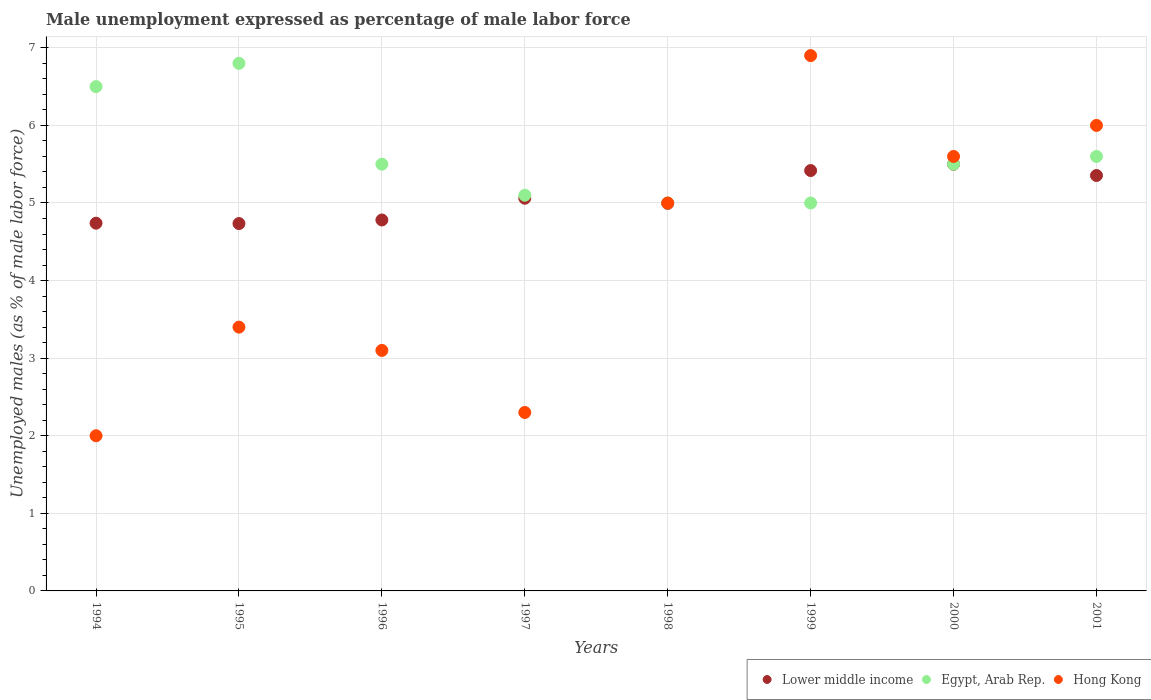Across all years, what is the maximum unemployment in males in in Egypt, Arab Rep.?
Provide a short and direct response. 6.8. Across all years, what is the minimum unemployment in males in in Egypt, Arab Rep.?
Offer a terse response. 5. In which year was the unemployment in males in in Lower middle income maximum?
Your answer should be compact. 2000. In which year was the unemployment in males in in Lower middle income minimum?
Keep it short and to the point. 1995. What is the total unemployment in males in in Hong Kong in the graph?
Your answer should be compact. 34.3. What is the difference between the unemployment in males in in Lower middle income in 1996 and that in 2000?
Offer a very short reply. -0.72. What is the difference between the unemployment in males in in Lower middle income in 1994 and the unemployment in males in in Egypt, Arab Rep. in 2000?
Give a very brief answer. -0.76. What is the average unemployment in males in in Egypt, Arab Rep. per year?
Provide a succinct answer. 5.62. In the year 1997, what is the difference between the unemployment in males in in Hong Kong and unemployment in males in in Lower middle income?
Give a very brief answer. -2.76. In how many years, is the unemployment in males in in Hong Kong greater than 4.2 %?
Offer a very short reply. 4. What is the ratio of the unemployment in males in in Egypt, Arab Rep. in 1997 to that in 2001?
Ensure brevity in your answer.  0.91. What is the difference between the highest and the second highest unemployment in males in in Egypt, Arab Rep.?
Give a very brief answer. 0.3. What is the difference between the highest and the lowest unemployment in males in in Lower middle income?
Offer a terse response. 0.76. In how many years, is the unemployment in males in in Hong Kong greater than the average unemployment in males in in Hong Kong taken over all years?
Offer a terse response. 4. Is it the case that in every year, the sum of the unemployment in males in in Hong Kong and unemployment in males in in Lower middle income  is greater than the unemployment in males in in Egypt, Arab Rep.?
Your response must be concise. Yes. Does the unemployment in males in in Hong Kong monotonically increase over the years?
Provide a short and direct response. No. How many dotlines are there?
Keep it short and to the point. 3. What is the difference between two consecutive major ticks on the Y-axis?
Your answer should be compact. 1. Are the values on the major ticks of Y-axis written in scientific E-notation?
Provide a short and direct response. No. Does the graph contain grids?
Make the answer very short. Yes. How many legend labels are there?
Provide a succinct answer. 3. How are the legend labels stacked?
Provide a short and direct response. Horizontal. What is the title of the graph?
Keep it short and to the point. Male unemployment expressed as percentage of male labor force. Does "Somalia" appear as one of the legend labels in the graph?
Your answer should be very brief. No. What is the label or title of the Y-axis?
Provide a short and direct response. Unemployed males (as % of male labor force). What is the Unemployed males (as % of male labor force) in Lower middle income in 1994?
Keep it short and to the point. 4.74. What is the Unemployed males (as % of male labor force) in Egypt, Arab Rep. in 1994?
Offer a very short reply. 6.5. What is the Unemployed males (as % of male labor force) of Lower middle income in 1995?
Offer a very short reply. 4.74. What is the Unemployed males (as % of male labor force) in Egypt, Arab Rep. in 1995?
Provide a short and direct response. 6.8. What is the Unemployed males (as % of male labor force) of Hong Kong in 1995?
Your response must be concise. 3.4. What is the Unemployed males (as % of male labor force) in Lower middle income in 1996?
Your response must be concise. 4.78. What is the Unemployed males (as % of male labor force) in Hong Kong in 1996?
Your response must be concise. 3.1. What is the Unemployed males (as % of male labor force) of Lower middle income in 1997?
Make the answer very short. 5.06. What is the Unemployed males (as % of male labor force) of Egypt, Arab Rep. in 1997?
Offer a very short reply. 5.1. What is the Unemployed males (as % of male labor force) of Hong Kong in 1997?
Offer a terse response. 2.3. What is the Unemployed males (as % of male labor force) of Lower middle income in 1998?
Make the answer very short. 4.99. What is the Unemployed males (as % of male labor force) in Hong Kong in 1998?
Your response must be concise. 5. What is the Unemployed males (as % of male labor force) in Lower middle income in 1999?
Give a very brief answer. 5.42. What is the Unemployed males (as % of male labor force) of Hong Kong in 1999?
Provide a short and direct response. 6.9. What is the Unemployed males (as % of male labor force) in Lower middle income in 2000?
Make the answer very short. 5.5. What is the Unemployed males (as % of male labor force) in Egypt, Arab Rep. in 2000?
Keep it short and to the point. 5.5. What is the Unemployed males (as % of male labor force) in Hong Kong in 2000?
Ensure brevity in your answer.  5.6. What is the Unemployed males (as % of male labor force) in Lower middle income in 2001?
Give a very brief answer. 5.35. What is the Unemployed males (as % of male labor force) of Egypt, Arab Rep. in 2001?
Your response must be concise. 5.6. What is the Unemployed males (as % of male labor force) of Hong Kong in 2001?
Offer a very short reply. 6. Across all years, what is the maximum Unemployed males (as % of male labor force) in Lower middle income?
Give a very brief answer. 5.5. Across all years, what is the maximum Unemployed males (as % of male labor force) in Egypt, Arab Rep.?
Your response must be concise. 6.8. Across all years, what is the maximum Unemployed males (as % of male labor force) in Hong Kong?
Keep it short and to the point. 6.9. Across all years, what is the minimum Unemployed males (as % of male labor force) of Lower middle income?
Offer a very short reply. 4.74. Across all years, what is the minimum Unemployed males (as % of male labor force) in Egypt, Arab Rep.?
Your response must be concise. 5. What is the total Unemployed males (as % of male labor force) of Lower middle income in the graph?
Provide a short and direct response. 40.58. What is the total Unemployed males (as % of male labor force) in Egypt, Arab Rep. in the graph?
Your answer should be compact. 45. What is the total Unemployed males (as % of male labor force) of Hong Kong in the graph?
Provide a short and direct response. 34.3. What is the difference between the Unemployed males (as % of male labor force) in Lower middle income in 1994 and that in 1995?
Your answer should be very brief. 0. What is the difference between the Unemployed males (as % of male labor force) in Egypt, Arab Rep. in 1994 and that in 1995?
Ensure brevity in your answer.  -0.3. What is the difference between the Unemployed males (as % of male labor force) in Lower middle income in 1994 and that in 1996?
Ensure brevity in your answer.  -0.04. What is the difference between the Unemployed males (as % of male labor force) in Lower middle income in 1994 and that in 1997?
Your answer should be compact. -0.32. What is the difference between the Unemployed males (as % of male labor force) of Egypt, Arab Rep. in 1994 and that in 1997?
Your answer should be very brief. 1.4. What is the difference between the Unemployed males (as % of male labor force) in Lower middle income in 1994 and that in 1998?
Your answer should be very brief. -0.25. What is the difference between the Unemployed males (as % of male labor force) in Hong Kong in 1994 and that in 1998?
Make the answer very short. -3. What is the difference between the Unemployed males (as % of male labor force) of Lower middle income in 1994 and that in 1999?
Provide a succinct answer. -0.68. What is the difference between the Unemployed males (as % of male labor force) in Egypt, Arab Rep. in 1994 and that in 1999?
Provide a succinct answer. 1.5. What is the difference between the Unemployed males (as % of male labor force) in Lower middle income in 1994 and that in 2000?
Your answer should be compact. -0.76. What is the difference between the Unemployed males (as % of male labor force) in Egypt, Arab Rep. in 1994 and that in 2000?
Keep it short and to the point. 1. What is the difference between the Unemployed males (as % of male labor force) in Lower middle income in 1994 and that in 2001?
Offer a terse response. -0.61. What is the difference between the Unemployed males (as % of male labor force) in Egypt, Arab Rep. in 1994 and that in 2001?
Make the answer very short. 0.9. What is the difference between the Unemployed males (as % of male labor force) in Hong Kong in 1994 and that in 2001?
Make the answer very short. -4. What is the difference between the Unemployed males (as % of male labor force) of Lower middle income in 1995 and that in 1996?
Keep it short and to the point. -0.05. What is the difference between the Unemployed males (as % of male labor force) of Hong Kong in 1995 and that in 1996?
Offer a very short reply. 0.3. What is the difference between the Unemployed males (as % of male labor force) in Lower middle income in 1995 and that in 1997?
Keep it short and to the point. -0.33. What is the difference between the Unemployed males (as % of male labor force) in Lower middle income in 1995 and that in 1998?
Your answer should be very brief. -0.26. What is the difference between the Unemployed males (as % of male labor force) in Egypt, Arab Rep. in 1995 and that in 1998?
Keep it short and to the point. 1.8. What is the difference between the Unemployed males (as % of male labor force) of Lower middle income in 1995 and that in 1999?
Keep it short and to the point. -0.68. What is the difference between the Unemployed males (as % of male labor force) of Egypt, Arab Rep. in 1995 and that in 1999?
Make the answer very short. 1.8. What is the difference between the Unemployed males (as % of male labor force) of Hong Kong in 1995 and that in 1999?
Offer a very short reply. -3.5. What is the difference between the Unemployed males (as % of male labor force) of Lower middle income in 1995 and that in 2000?
Make the answer very short. -0.76. What is the difference between the Unemployed males (as % of male labor force) of Egypt, Arab Rep. in 1995 and that in 2000?
Your answer should be compact. 1.3. What is the difference between the Unemployed males (as % of male labor force) of Hong Kong in 1995 and that in 2000?
Keep it short and to the point. -2.2. What is the difference between the Unemployed males (as % of male labor force) in Lower middle income in 1995 and that in 2001?
Offer a terse response. -0.62. What is the difference between the Unemployed males (as % of male labor force) of Hong Kong in 1995 and that in 2001?
Give a very brief answer. -2.6. What is the difference between the Unemployed males (as % of male labor force) in Lower middle income in 1996 and that in 1997?
Your response must be concise. -0.28. What is the difference between the Unemployed males (as % of male labor force) of Egypt, Arab Rep. in 1996 and that in 1997?
Give a very brief answer. 0.4. What is the difference between the Unemployed males (as % of male labor force) in Lower middle income in 1996 and that in 1998?
Your answer should be very brief. -0.21. What is the difference between the Unemployed males (as % of male labor force) in Egypt, Arab Rep. in 1996 and that in 1998?
Provide a succinct answer. 0.5. What is the difference between the Unemployed males (as % of male labor force) in Hong Kong in 1996 and that in 1998?
Ensure brevity in your answer.  -1.9. What is the difference between the Unemployed males (as % of male labor force) in Lower middle income in 1996 and that in 1999?
Make the answer very short. -0.64. What is the difference between the Unemployed males (as % of male labor force) in Egypt, Arab Rep. in 1996 and that in 1999?
Your response must be concise. 0.5. What is the difference between the Unemployed males (as % of male labor force) in Hong Kong in 1996 and that in 1999?
Provide a short and direct response. -3.8. What is the difference between the Unemployed males (as % of male labor force) in Lower middle income in 1996 and that in 2000?
Your answer should be compact. -0.72. What is the difference between the Unemployed males (as % of male labor force) of Egypt, Arab Rep. in 1996 and that in 2000?
Offer a terse response. 0. What is the difference between the Unemployed males (as % of male labor force) in Hong Kong in 1996 and that in 2000?
Keep it short and to the point. -2.5. What is the difference between the Unemployed males (as % of male labor force) in Lower middle income in 1996 and that in 2001?
Offer a terse response. -0.57. What is the difference between the Unemployed males (as % of male labor force) of Egypt, Arab Rep. in 1996 and that in 2001?
Your response must be concise. -0.1. What is the difference between the Unemployed males (as % of male labor force) in Lower middle income in 1997 and that in 1998?
Your answer should be compact. 0.07. What is the difference between the Unemployed males (as % of male labor force) of Lower middle income in 1997 and that in 1999?
Keep it short and to the point. -0.36. What is the difference between the Unemployed males (as % of male labor force) in Egypt, Arab Rep. in 1997 and that in 1999?
Provide a succinct answer. 0.1. What is the difference between the Unemployed males (as % of male labor force) in Hong Kong in 1997 and that in 1999?
Provide a short and direct response. -4.6. What is the difference between the Unemployed males (as % of male labor force) in Lower middle income in 1997 and that in 2000?
Your response must be concise. -0.44. What is the difference between the Unemployed males (as % of male labor force) of Egypt, Arab Rep. in 1997 and that in 2000?
Provide a succinct answer. -0.4. What is the difference between the Unemployed males (as % of male labor force) in Lower middle income in 1997 and that in 2001?
Provide a succinct answer. -0.29. What is the difference between the Unemployed males (as % of male labor force) in Lower middle income in 1998 and that in 1999?
Your answer should be very brief. -0.42. What is the difference between the Unemployed males (as % of male labor force) of Egypt, Arab Rep. in 1998 and that in 1999?
Offer a terse response. 0. What is the difference between the Unemployed males (as % of male labor force) of Hong Kong in 1998 and that in 1999?
Your answer should be very brief. -1.9. What is the difference between the Unemployed males (as % of male labor force) of Lower middle income in 1998 and that in 2000?
Your answer should be compact. -0.51. What is the difference between the Unemployed males (as % of male labor force) in Lower middle income in 1998 and that in 2001?
Keep it short and to the point. -0.36. What is the difference between the Unemployed males (as % of male labor force) of Egypt, Arab Rep. in 1998 and that in 2001?
Keep it short and to the point. -0.6. What is the difference between the Unemployed males (as % of male labor force) of Hong Kong in 1998 and that in 2001?
Offer a terse response. -1. What is the difference between the Unemployed males (as % of male labor force) of Lower middle income in 1999 and that in 2000?
Offer a terse response. -0.08. What is the difference between the Unemployed males (as % of male labor force) in Egypt, Arab Rep. in 1999 and that in 2000?
Make the answer very short. -0.5. What is the difference between the Unemployed males (as % of male labor force) of Lower middle income in 1999 and that in 2001?
Your response must be concise. 0.06. What is the difference between the Unemployed males (as % of male labor force) of Egypt, Arab Rep. in 1999 and that in 2001?
Offer a terse response. -0.6. What is the difference between the Unemployed males (as % of male labor force) in Lower middle income in 2000 and that in 2001?
Your answer should be very brief. 0.14. What is the difference between the Unemployed males (as % of male labor force) of Lower middle income in 1994 and the Unemployed males (as % of male labor force) of Egypt, Arab Rep. in 1995?
Offer a very short reply. -2.06. What is the difference between the Unemployed males (as % of male labor force) of Lower middle income in 1994 and the Unemployed males (as % of male labor force) of Hong Kong in 1995?
Give a very brief answer. 1.34. What is the difference between the Unemployed males (as % of male labor force) of Lower middle income in 1994 and the Unemployed males (as % of male labor force) of Egypt, Arab Rep. in 1996?
Provide a short and direct response. -0.76. What is the difference between the Unemployed males (as % of male labor force) of Lower middle income in 1994 and the Unemployed males (as % of male labor force) of Hong Kong in 1996?
Your answer should be very brief. 1.64. What is the difference between the Unemployed males (as % of male labor force) in Lower middle income in 1994 and the Unemployed males (as % of male labor force) in Egypt, Arab Rep. in 1997?
Offer a very short reply. -0.36. What is the difference between the Unemployed males (as % of male labor force) in Lower middle income in 1994 and the Unemployed males (as % of male labor force) in Hong Kong in 1997?
Give a very brief answer. 2.44. What is the difference between the Unemployed males (as % of male labor force) in Lower middle income in 1994 and the Unemployed males (as % of male labor force) in Egypt, Arab Rep. in 1998?
Offer a very short reply. -0.26. What is the difference between the Unemployed males (as % of male labor force) in Lower middle income in 1994 and the Unemployed males (as % of male labor force) in Hong Kong in 1998?
Make the answer very short. -0.26. What is the difference between the Unemployed males (as % of male labor force) in Lower middle income in 1994 and the Unemployed males (as % of male labor force) in Egypt, Arab Rep. in 1999?
Your response must be concise. -0.26. What is the difference between the Unemployed males (as % of male labor force) in Lower middle income in 1994 and the Unemployed males (as % of male labor force) in Hong Kong in 1999?
Your answer should be very brief. -2.16. What is the difference between the Unemployed males (as % of male labor force) in Lower middle income in 1994 and the Unemployed males (as % of male labor force) in Egypt, Arab Rep. in 2000?
Give a very brief answer. -0.76. What is the difference between the Unemployed males (as % of male labor force) of Lower middle income in 1994 and the Unemployed males (as % of male labor force) of Hong Kong in 2000?
Your response must be concise. -0.86. What is the difference between the Unemployed males (as % of male labor force) in Lower middle income in 1994 and the Unemployed males (as % of male labor force) in Egypt, Arab Rep. in 2001?
Provide a succinct answer. -0.86. What is the difference between the Unemployed males (as % of male labor force) of Lower middle income in 1994 and the Unemployed males (as % of male labor force) of Hong Kong in 2001?
Your answer should be compact. -1.26. What is the difference between the Unemployed males (as % of male labor force) of Egypt, Arab Rep. in 1994 and the Unemployed males (as % of male labor force) of Hong Kong in 2001?
Provide a succinct answer. 0.5. What is the difference between the Unemployed males (as % of male labor force) of Lower middle income in 1995 and the Unemployed males (as % of male labor force) of Egypt, Arab Rep. in 1996?
Provide a short and direct response. -0.76. What is the difference between the Unemployed males (as % of male labor force) in Lower middle income in 1995 and the Unemployed males (as % of male labor force) in Hong Kong in 1996?
Provide a succinct answer. 1.64. What is the difference between the Unemployed males (as % of male labor force) of Egypt, Arab Rep. in 1995 and the Unemployed males (as % of male labor force) of Hong Kong in 1996?
Keep it short and to the point. 3.7. What is the difference between the Unemployed males (as % of male labor force) of Lower middle income in 1995 and the Unemployed males (as % of male labor force) of Egypt, Arab Rep. in 1997?
Offer a terse response. -0.36. What is the difference between the Unemployed males (as % of male labor force) of Lower middle income in 1995 and the Unemployed males (as % of male labor force) of Hong Kong in 1997?
Keep it short and to the point. 2.44. What is the difference between the Unemployed males (as % of male labor force) in Egypt, Arab Rep. in 1995 and the Unemployed males (as % of male labor force) in Hong Kong in 1997?
Provide a short and direct response. 4.5. What is the difference between the Unemployed males (as % of male labor force) of Lower middle income in 1995 and the Unemployed males (as % of male labor force) of Egypt, Arab Rep. in 1998?
Offer a terse response. -0.26. What is the difference between the Unemployed males (as % of male labor force) in Lower middle income in 1995 and the Unemployed males (as % of male labor force) in Hong Kong in 1998?
Your answer should be compact. -0.26. What is the difference between the Unemployed males (as % of male labor force) of Egypt, Arab Rep. in 1995 and the Unemployed males (as % of male labor force) of Hong Kong in 1998?
Provide a succinct answer. 1.8. What is the difference between the Unemployed males (as % of male labor force) in Lower middle income in 1995 and the Unemployed males (as % of male labor force) in Egypt, Arab Rep. in 1999?
Ensure brevity in your answer.  -0.26. What is the difference between the Unemployed males (as % of male labor force) of Lower middle income in 1995 and the Unemployed males (as % of male labor force) of Hong Kong in 1999?
Ensure brevity in your answer.  -2.16. What is the difference between the Unemployed males (as % of male labor force) in Egypt, Arab Rep. in 1995 and the Unemployed males (as % of male labor force) in Hong Kong in 1999?
Make the answer very short. -0.1. What is the difference between the Unemployed males (as % of male labor force) of Lower middle income in 1995 and the Unemployed males (as % of male labor force) of Egypt, Arab Rep. in 2000?
Give a very brief answer. -0.76. What is the difference between the Unemployed males (as % of male labor force) in Lower middle income in 1995 and the Unemployed males (as % of male labor force) in Hong Kong in 2000?
Your response must be concise. -0.86. What is the difference between the Unemployed males (as % of male labor force) of Egypt, Arab Rep. in 1995 and the Unemployed males (as % of male labor force) of Hong Kong in 2000?
Your response must be concise. 1.2. What is the difference between the Unemployed males (as % of male labor force) of Lower middle income in 1995 and the Unemployed males (as % of male labor force) of Egypt, Arab Rep. in 2001?
Your response must be concise. -0.86. What is the difference between the Unemployed males (as % of male labor force) in Lower middle income in 1995 and the Unemployed males (as % of male labor force) in Hong Kong in 2001?
Keep it short and to the point. -1.26. What is the difference between the Unemployed males (as % of male labor force) in Lower middle income in 1996 and the Unemployed males (as % of male labor force) in Egypt, Arab Rep. in 1997?
Provide a succinct answer. -0.32. What is the difference between the Unemployed males (as % of male labor force) of Lower middle income in 1996 and the Unemployed males (as % of male labor force) of Hong Kong in 1997?
Your answer should be compact. 2.48. What is the difference between the Unemployed males (as % of male labor force) in Lower middle income in 1996 and the Unemployed males (as % of male labor force) in Egypt, Arab Rep. in 1998?
Ensure brevity in your answer.  -0.22. What is the difference between the Unemployed males (as % of male labor force) in Lower middle income in 1996 and the Unemployed males (as % of male labor force) in Hong Kong in 1998?
Give a very brief answer. -0.22. What is the difference between the Unemployed males (as % of male labor force) of Lower middle income in 1996 and the Unemployed males (as % of male labor force) of Egypt, Arab Rep. in 1999?
Provide a succinct answer. -0.22. What is the difference between the Unemployed males (as % of male labor force) of Lower middle income in 1996 and the Unemployed males (as % of male labor force) of Hong Kong in 1999?
Offer a terse response. -2.12. What is the difference between the Unemployed males (as % of male labor force) of Egypt, Arab Rep. in 1996 and the Unemployed males (as % of male labor force) of Hong Kong in 1999?
Offer a terse response. -1.4. What is the difference between the Unemployed males (as % of male labor force) in Lower middle income in 1996 and the Unemployed males (as % of male labor force) in Egypt, Arab Rep. in 2000?
Your response must be concise. -0.72. What is the difference between the Unemployed males (as % of male labor force) in Lower middle income in 1996 and the Unemployed males (as % of male labor force) in Hong Kong in 2000?
Your answer should be very brief. -0.82. What is the difference between the Unemployed males (as % of male labor force) of Egypt, Arab Rep. in 1996 and the Unemployed males (as % of male labor force) of Hong Kong in 2000?
Keep it short and to the point. -0.1. What is the difference between the Unemployed males (as % of male labor force) of Lower middle income in 1996 and the Unemployed males (as % of male labor force) of Egypt, Arab Rep. in 2001?
Provide a short and direct response. -0.82. What is the difference between the Unemployed males (as % of male labor force) in Lower middle income in 1996 and the Unemployed males (as % of male labor force) in Hong Kong in 2001?
Provide a succinct answer. -1.22. What is the difference between the Unemployed males (as % of male labor force) in Egypt, Arab Rep. in 1996 and the Unemployed males (as % of male labor force) in Hong Kong in 2001?
Keep it short and to the point. -0.5. What is the difference between the Unemployed males (as % of male labor force) of Lower middle income in 1997 and the Unemployed males (as % of male labor force) of Egypt, Arab Rep. in 1998?
Give a very brief answer. 0.06. What is the difference between the Unemployed males (as % of male labor force) of Lower middle income in 1997 and the Unemployed males (as % of male labor force) of Hong Kong in 1998?
Make the answer very short. 0.06. What is the difference between the Unemployed males (as % of male labor force) in Lower middle income in 1997 and the Unemployed males (as % of male labor force) in Egypt, Arab Rep. in 1999?
Keep it short and to the point. 0.06. What is the difference between the Unemployed males (as % of male labor force) of Lower middle income in 1997 and the Unemployed males (as % of male labor force) of Hong Kong in 1999?
Your response must be concise. -1.84. What is the difference between the Unemployed males (as % of male labor force) of Lower middle income in 1997 and the Unemployed males (as % of male labor force) of Egypt, Arab Rep. in 2000?
Ensure brevity in your answer.  -0.44. What is the difference between the Unemployed males (as % of male labor force) in Lower middle income in 1997 and the Unemployed males (as % of male labor force) in Hong Kong in 2000?
Give a very brief answer. -0.54. What is the difference between the Unemployed males (as % of male labor force) in Lower middle income in 1997 and the Unemployed males (as % of male labor force) in Egypt, Arab Rep. in 2001?
Provide a short and direct response. -0.54. What is the difference between the Unemployed males (as % of male labor force) in Lower middle income in 1997 and the Unemployed males (as % of male labor force) in Hong Kong in 2001?
Give a very brief answer. -0.94. What is the difference between the Unemployed males (as % of male labor force) in Egypt, Arab Rep. in 1997 and the Unemployed males (as % of male labor force) in Hong Kong in 2001?
Ensure brevity in your answer.  -0.9. What is the difference between the Unemployed males (as % of male labor force) of Lower middle income in 1998 and the Unemployed males (as % of male labor force) of Egypt, Arab Rep. in 1999?
Provide a short and direct response. -0.01. What is the difference between the Unemployed males (as % of male labor force) in Lower middle income in 1998 and the Unemployed males (as % of male labor force) in Hong Kong in 1999?
Your answer should be very brief. -1.91. What is the difference between the Unemployed males (as % of male labor force) in Egypt, Arab Rep. in 1998 and the Unemployed males (as % of male labor force) in Hong Kong in 1999?
Keep it short and to the point. -1.9. What is the difference between the Unemployed males (as % of male labor force) of Lower middle income in 1998 and the Unemployed males (as % of male labor force) of Egypt, Arab Rep. in 2000?
Your answer should be very brief. -0.51. What is the difference between the Unemployed males (as % of male labor force) in Lower middle income in 1998 and the Unemployed males (as % of male labor force) in Hong Kong in 2000?
Offer a terse response. -0.61. What is the difference between the Unemployed males (as % of male labor force) in Lower middle income in 1998 and the Unemployed males (as % of male labor force) in Egypt, Arab Rep. in 2001?
Provide a short and direct response. -0.61. What is the difference between the Unemployed males (as % of male labor force) of Lower middle income in 1998 and the Unemployed males (as % of male labor force) of Hong Kong in 2001?
Give a very brief answer. -1.01. What is the difference between the Unemployed males (as % of male labor force) of Egypt, Arab Rep. in 1998 and the Unemployed males (as % of male labor force) of Hong Kong in 2001?
Your response must be concise. -1. What is the difference between the Unemployed males (as % of male labor force) in Lower middle income in 1999 and the Unemployed males (as % of male labor force) in Egypt, Arab Rep. in 2000?
Your answer should be very brief. -0.08. What is the difference between the Unemployed males (as % of male labor force) of Lower middle income in 1999 and the Unemployed males (as % of male labor force) of Hong Kong in 2000?
Offer a very short reply. -0.18. What is the difference between the Unemployed males (as % of male labor force) in Egypt, Arab Rep. in 1999 and the Unemployed males (as % of male labor force) in Hong Kong in 2000?
Keep it short and to the point. -0.6. What is the difference between the Unemployed males (as % of male labor force) of Lower middle income in 1999 and the Unemployed males (as % of male labor force) of Egypt, Arab Rep. in 2001?
Provide a succinct answer. -0.18. What is the difference between the Unemployed males (as % of male labor force) in Lower middle income in 1999 and the Unemployed males (as % of male labor force) in Hong Kong in 2001?
Provide a succinct answer. -0.58. What is the difference between the Unemployed males (as % of male labor force) of Egypt, Arab Rep. in 1999 and the Unemployed males (as % of male labor force) of Hong Kong in 2001?
Offer a very short reply. -1. What is the difference between the Unemployed males (as % of male labor force) in Lower middle income in 2000 and the Unemployed males (as % of male labor force) in Egypt, Arab Rep. in 2001?
Keep it short and to the point. -0.1. What is the difference between the Unemployed males (as % of male labor force) of Lower middle income in 2000 and the Unemployed males (as % of male labor force) of Hong Kong in 2001?
Your response must be concise. -0.5. What is the difference between the Unemployed males (as % of male labor force) in Egypt, Arab Rep. in 2000 and the Unemployed males (as % of male labor force) in Hong Kong in 2001?
Offer a terse response. -0.5. What is the average Unemployed males (as % of male labor force) in Lower middle income per year?
Your answer should be compact. 5.07. What is the average Unemployed males (as % of male labor force) of Egypt, Arab Rep. per year?
Give a very brief answer. 5.62. What is the average Unemployed males (as % of male labor force) of Hong Kong per year?
Provide a short and direct response. 4.29. In the year 1994, what is the difference between the Unemployed males (as % of male labor force) of Lower middle income and Unemployed males (as % of male labor force) of Egypt, Arab Rep.?
Give a very brief answer. -1.76. In the year 1994, what is the difference between the Unemployed males (as % of male labor force) in Lower middle income and Unemployed males (as % of male labor force) in Hong Kong?
Give a very brief answer. 2.74. In the year 1994, what is the difference between the Unemployed males (as % of male labor force) of Egypt, Arab Rep. and Unemployed males (as % of male labor force) of Hong Kong?
Make the answer very short. 4.5. In the year 1995, what is the difference between the Unemployed males (as % of male labor force) of Lower middle income and Unemployed males (as % of male labor force) of Egypt, Arab Rep.?
Your answer should be very brief. -2.06. In the year 1995, what is the difference between the Unemployed males (as % of male labor force) in Lower middle income and Unemployed males (as % of male labor force) in Hong Kong?
Your answer should be very brief. 1.34. In the year 1996, what is the difference between the Unemployed males (as % of male labor force) in Lower middle income and Unemployed males (as % of male labor force) in Egypt, Arab Rep.?
Give a very brief answer. -0.72. In the year 1996, what is the difference between the Unemployed males (as % of male labor force) in Lower middle income and Unemployed males (as % of male labor force) in Hong Kong?
Your answer should be very brief. 1.68. In the year 1997, what is the difference between the Unemployed males (as % of male labor force) of Lower middle income and Unemployed males (as % of male labor force) of Egypt, Arab Rep.?
Provide a short and direct response. -0.04. In the year 1997, what is the difference between the Unemployed males (as % of male labor force) of Lower middle income and Unemployed males (as % of male labor force) of Hong Kong?
Your response must be concise. 2.76. In the year 1997, what is the difference between the Unemployed males (as % of male labor force) of Egypt, Arab Rep. and Unemployed males (as % of male labor force) of Hong Kong?
Give a very brief answer. 2.8. In the year 1998, what is the difference between the Unemployed males (as % of male labor force) of Lower middle income and Unemployed males (as % of male labor force) of Egypt, Arab Rep.?
Your answer should be compact. -0.01. In the year 1998, what is the difference between the Unemployed males (as % of male labor force) of Lower middle income and Unemployed males (as % of male labor force) of Hong Kong?
Your response must be concise. -0.01. In the year 1999, what is the difference between the Unemployed males (as % of male labor force) of Lower middle income and Unemployed males (as % of male labor force) of Egypt, Arab Rep.?
Your answer should be compact. 0.42. In the year 1999, what is the difference between the Unemployed males (as % of male labor force) in Lower middle income and Unemployed males (as % of male labor force) in Hong Kong?
Your answer should be compact. -1.48. In the year 1999, what is the difference between the Unemployed males (as % of male labor force) of Egypt, Arab Rep. and Unemployed males (as % of male labor force) of Hong Kong?
Give a very brief answer. -1.9. In the year 2000, what is the difference between the Unemployed males (as % of male labor force) in Lower middle income and Unemployed males (as % of male labor force) in Egypt, Arab Rep.?
Provide a short and direct response. -0. In the year 2000, what is the difference between the Unemployed males (as % of male labor force) in Lower middle income and Unemployed males (as % of male labor force) in Hong Kong?
Your answer should be very brief. -0.1. In the year 2000, what is the difference between the Unemployed males (as % of male labor force) of Egypt, Arab Rep. and Unemployed males (as % of male labor force) of Hong Kong?
Ensure brevity in your answer.  -0.1. In the year 2001, what is the difference between the Unemployed males (as % of male labor force) of Lower middle income and Unemployed males (as % of male labor force) of Egypt, Arab Rep.?
Ensure brevity in your answer.  -0.25. In the year 2001, what is the difference between the Unemployed males (as % of male labor force) of Lower middle income and Unemployed males (as % of male labor force) of Hong Kong?
Keep it short and to the point. -0.65. In the year 2001, what is the difference between the Unemployed males (as % of male labor force) of Egypt, Arab Rep. and Unemployed males (as % of male labor force) of Hong Kong?
Make the answer very short. -0.4. What is the ratio of the Unemployed males (as % of male labor force) of Lower middle income in 1994 to that in 1995?
Your answer should be compact. 1. What is the ratio of the Unemployed males (as % of male labor force) in Egypt, Arab Rep. in 1994 to that in 1995?
Your answer should be compact. 0.96. What is the ratio of the Unemployed males (as % of male labor force) in Hong Kong in 1994 to that in 1995?
Keep it short and to the point. 0.59. What is the ratio of the Unemployed males (as % of male labor force) of Egypt, Arab Rep. in 1994 to that in 1996?
Keep it short and to the point. 1.18. What is the ratio of the Unemployed males (as % of male labor force) in Hong Kong in 1994 to that in 1996?
Your response must be concise. 0.65. What is the ratio of the Unemployed males (as % of male labor force) in Lower middle income in 1994 to that in 1997?
Make the answer very short. 0.94. What is the ratio of the Unemployed males (as % of male labor force) of Egypt, Arab Rep. in 1994 to that in 1997?
Your answer should be very brief. 1.27. What is the ratio of the Unemployed males (as % of male labor force) in Hong Kong in 1994 to that in 1997?
Ensure brevity in your answer.  0.87. What is the ratio of the Unemployed males (as % of male labor force) in Lower middle income in 1994 to that in 1998?
Your answer should be very brief. 0.95. What is the ratio of the Unemployed males (as % of male labor force) of Egypt, Arab Rep. in 1994 to that in 1998?
Keep it short and to the point. 1.3. What is the ratio of the Unemployed males (as % of male labor force) of Lower middle income in 1994 to that in 1999?
Offer a very short reply. 0.87. What is the ratio of the Unemployed males (as % of male labor force) of Egypt, Arab Rep. in 1994 to that in 1999?
Keep it short and to the point. 1.3. What is the ratio of the Unemployed males (as % of male labor force) in Hong Kong in 1994 to that in 1999?
Offer a terse response. 0.29. What is the ratio of the Unemployed males (as % of male labor force) of Lower middle income in 1994 to that in 2000?
Offer a very short reply. 0.86. What is the ratio of the Unemployed males (as % of male labor force) of Egypt, Arab Rep. in 1994 to that in 2000?
Your answer should be very brief. 1.18. What is the ratio of the Unemployed males (as % of male labor force) in Hong Kong in 1994 to that in 2000?
Make the answer very short. 0.36. What is the ratio of the Unemployed males (as % of male labor force) in Lower middle income in 1994 to that in 2001?
Your response must be concise. 0.89. What is the ratio of the Unemployed males (as % of male labor force) in Egypt, Arab Rep. in 1994 to that in 2001?
Your response must be concise. 1.16. What is the ratio of the Unemployed males (as % of male labor force) of Lower middle income in 1995 to that in 1996?
Ensure brevity in your answer.  0.99. What is the ratio of the Unemployed males (as % of male labor force) in Egypt, Arab Rep. in 1995 to that in 1996?
Your answer should be compact. 1.24. What is the ratio of the Unemployed males (as % of male labor force) of Hong Kong in 1995 to that in 1996?
Your answer should be compact. 1.1. What is the ratio of the Unemployed males (as % of male labor force) in Lower middle income in 1995 to that in 1997?
Offer a very short reply. 0.94. What is the ratio of the Unemployed males (as % of male labor force) of Hong Kong in 1995 to that in 1997?
Your response must be concise. 1.48. What is the ratio of the Unemployed males (as % of male labor force) of Lower middle income in 1995 to that in 1998?
Ensure brevity in your answer.  0.95. What is the ratio of the Unemployed males (as % of male labor force) of Egypt, Arab Rep. in 1995 to that in 1998?
Offer a terse response. 1.36. What is the ratio of the Unemployed males (as % of male labor force) of Hong Kong in 1995 to that in 1998?
Make the answer very short. 0.68. What is the ratio of the Unemployed males (as % of male labor force) of Lower middle income in 1995 to that in 1999?
Your answer should be very brief. 0.87. What is the ratio of the Unemployed males (as % of male labor force) of Egypt, Arab Rep. in 1995 to that in 1999?
Your answer should be compact. 1.36. What is the ratio of the Unemployed males (as % of male labor force) of Hong Kong in 1995 to that in 1999?
Give a very brief answer. 0.49. What is the ratio of the Unemployed males (as % of male labor force) of Lower middle income in 1995 to that in 2000?
Your response must be concise. 0.86. What is the ratio of the Unemployed males (as % of male labor force) in Egypt, Arab Rep. in 1995 to that in 2000?
Your answer should be very brief. 1.24. What is the ratio of the Unemployed males (as % of male labor force) in Hong Kong in 1995 to that in 2000?
Ensure brevity in your answer.  0.61. What is the ratio of the Unemployed males (as % of male labor force) of Lower middle income in 1995 to that in 2001?
Make the answer very short. 0.88. What is the ratio of the Unemployed males (as % of male labor force) of Egypt, Arab Rep. in 1995 to that in 2001?
Provide a succinct answer. 1.21. What is the ratio of the Unemployed males (as % of male labor force) of Hong Kong in 1995 to that in 2001?
Offer a very short reply. 0.57. What is the ratio of the Unemployed males (as % of male labor force) in Lower middle income in 1996 to that in 1997?
Offer a very short reply. 0.94. What is the ratio of the Unemployed males (as % of male labor force) of Egypt, Arab Rep. in 1996 to that in 1997?
Ensure brevity in your answer.  1.08. What is the ratio of the Unemployed males (as % of male labor force) of Hong Kong in 1996 to that in 1997?
Provide a succinct answer. 1.35. What is the ratio of the Unemployed males (as % of male labor force) of Lower middle income in 1996 to that in 1998?
Your response must be concise. 0.96. What is the ratio of the Unemployed males (as % of male labor force) of Hong Kong in 1996 to that in 1998?
Ensure brevity in your answer.  0.62. What is the ratio of the Unemployed males (as % of male labor force) in Lower middle income in 1996 to that in 1999?
Your response must be concise. 0.88. What is the ratio of the Unemployed males (as % of male labor force) of Egypt, Arab Rep. in 1996 to that in 1999?
Make the answer very short. 1.1. What is the ratio of the Unemployed males (as % of male labor force) in Hong Kong in 1996 to that in 1999?
Make the answer very short. 0.45. What is the ratio of the Unemployed males (as % of male labor force) of Lower middle income in 1996 to that in 2000?
Provide a short and direct response. 0.87. What is the ratio of the Unemployed males (as % of male labor force) of Hong Kong in 1996 to that in 2000?
Give a very brief answer. 0.55. What is the ratio of the Unemployed males (as % of male labor force) of Lower middle income in 1996 to that in 2001?
Provide a short and direct response. 0.89. What is the ratio of the Unemployed males (as % of male labor force) in Egypt, Arab Rep. in 1996 to that in 2001?
Ensure brevity in your answer.  0.98. What is the ratio of the Unemployed males (as % of male labor force) in Hong Kong in 1996 to that in 2001?
Ensure brevity in your answer.  0.52. What is the ratio of the Unemployed males (as % of male labor force) in Lower middle income in 1997 to that in 1998?
Provide a succinct answer. 1.01. What is the ratio of the Unemployed males (as % of male labor force) in Egypt, Arab Rep. in 1997 to that in 1998?
Offer a terse response. 1.02. What is the ratio of the Unemployed males (as % of male labor force) in Hong Kong in 1997 to that in 1998?
Make the answer very short. 0.46. What is the ratio of the Unemployed males (as % of male labor force) of Lower middle income in 1997 to that in 1999?
Your answer should be very brief. 0.93. What is the ratio of the Unemployed males (as % of male labor force) in Egypt, Arab Rep. in 1997 to that in 1999?
Provide a short and direct response. 1.02. What is the ratio of the Unemployed males (as % of male labor force) of Hong Kong in 1997 to that in 1999?
Your answer should be very brief. 0.33. What is the ratio of the Unemployed males (as % of male labor force) of Lower middle income in 1997 to that in 2000?
Offer a terse response. 0.92. What is the ratio of the Unemployed males (as % of male labor force) of Egypt, Arab Rep. in 1997 to that in 2000?
Your response must be concise. 0.93. What is the ratio of the Unemployed males (as % of male labor force) in Hong Kong in 1997 to that in 2000?
Make the answer very short. 0.41. What is the ratio of the Unemployed males (as % of male labor force) in Lower middle income in 1997 to that in 2001?
Provide a short and direct response. 0.95. What is the ratio of the Unemployed males (as % of male labor force) in Egypt, Arab Rep. in 1997 to that in 2001?
Give a very brief answer. 0.91. What is the ratio of the Unemployed males (as % of male labor force) in Hong Kong in 1997 to that in 2001?
Your answer should be very brief. 0.38. What is the ratio of the Unemployed males (as % of male labor force) in Lower middle income in 1998 to that in 1999?
Ensure brevity in your answer.  0.92. What is the ratio of the Unemployed males (as % of male labor force) in Hong Kong in 1998 to that in 1999?
Offer a terse response. 0.72. What is the ratio of the Unemployed males (as % of male labor force) in Lower middle income in 1998 to that in 2000?
Keep it short and to the point. 0.91. What is the ratio of the Unemployed males (as % of male labor force) in Egypt, Arab Rep. in 1998 to that in 2000?
Provide a succinct answer. 0.91. What is the ratio of the Unemployed males (as % of male labor force) of Hong Kong in 1998 to that in 2000?
Keep it short and to the point. 0.89. What is the ratio of the Unemployed males (as % of male labor force) of Lower middle income in 1998 to that in 2001?
Make the answer very short. 0.93. What is the ratio of the Unemployed males (as % of male labor force) in Egypt, Arab Rep. in 1998 to that in 2001?
Your answer should be very brief. 0.89. What is the ratio of the Unemployed males (as % of male labor force) of Hong Kong in 1998 to that in 2001?
Your response must be concise. 0.83. What is the ratio of the Unemployed males (as % of male labor force) of Lower middle income in 1999 to that in 2000?
Keep it short and to the point. 0.99. What is the ratio of the Unemployed males (as % of male labor force) in Egypt, Arab Rep. in 1999 to that in 2000?
Your response must be concise. 0.91. What is the ratio of the Unemployed males (as % of male labor force) of Hong Kong in 1999 to that in 2000?
Keep it short and to the point. 1.23. What is the ratio of the Unemployed males (as % of male labor force) of Lower middle income in 1999 to that in 2001?
Ensure brevity in your answer.  1.01. What is the ratio of the Unemployed males (as % of male labor force) in Egypt, Arab Rep. in 1999 to that in 2001?
Make the answer very short. 0.89. What is the ratio of the Unemployed males (as % of male labor force) of Hong Kong in 1999 to that in 2001?
Make the answer very short. 1.15. What is the ratio of the Unemployed males (as % of male labor force) in Lower middle income in 2000 to that in 2001?
Provide a short and direct response. 1.03. What is the ratio of the Unemployed males (as % of male labor force) in Egypt, Arab Rep. in 2000 to that in 2001?
Your answer should be very brief. 0.98. What is the difference between the highest and the second highest Unemployed males (as % of male labor force) in Lower middle income?
Your response must be concise. 0.08. What is the difference between the highest and the second highest Unemployed males (as % of male labor force) of Hong Kong?
Your response must be concise. 0.9. What is the difference between the highest and the lowest Unemployed males (as % of male labor force) of Lower middle income?
Ensure brevity in your answer.  0.76. What is the difference between the highest and the lowest Unemployed males (as % of male labor force) of Egypt, Arab Rep.?
Ensure brevity in your answer.  1.8. What is the difference between the highest and the lowest Unemployed males (as % of male labor force) in Hong Kong?
Offer a very short reply. 4.9. 